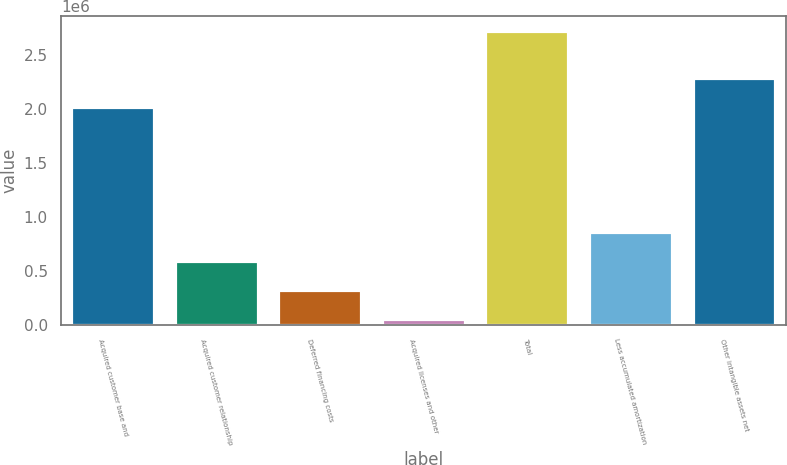Convert chart to OTSL. <chart><loc_0><loc_0><loc_500><loc_500><bar_chart><fcel>Acquired customer base and<fcel>Acquired customer relationship<fcel>Deferred financing costs<fcel>Acquired licenses and other<fcel>Total<fcel>Less accumulated amortization<fcel>Other intangible assets net<nl><fcel>2.01655e+06<fcel>590000<fcel>318920<fcel>51703<fcel>2.72387e+06<fcel>857217<fcel>2.28376e+06<nl></chart> 